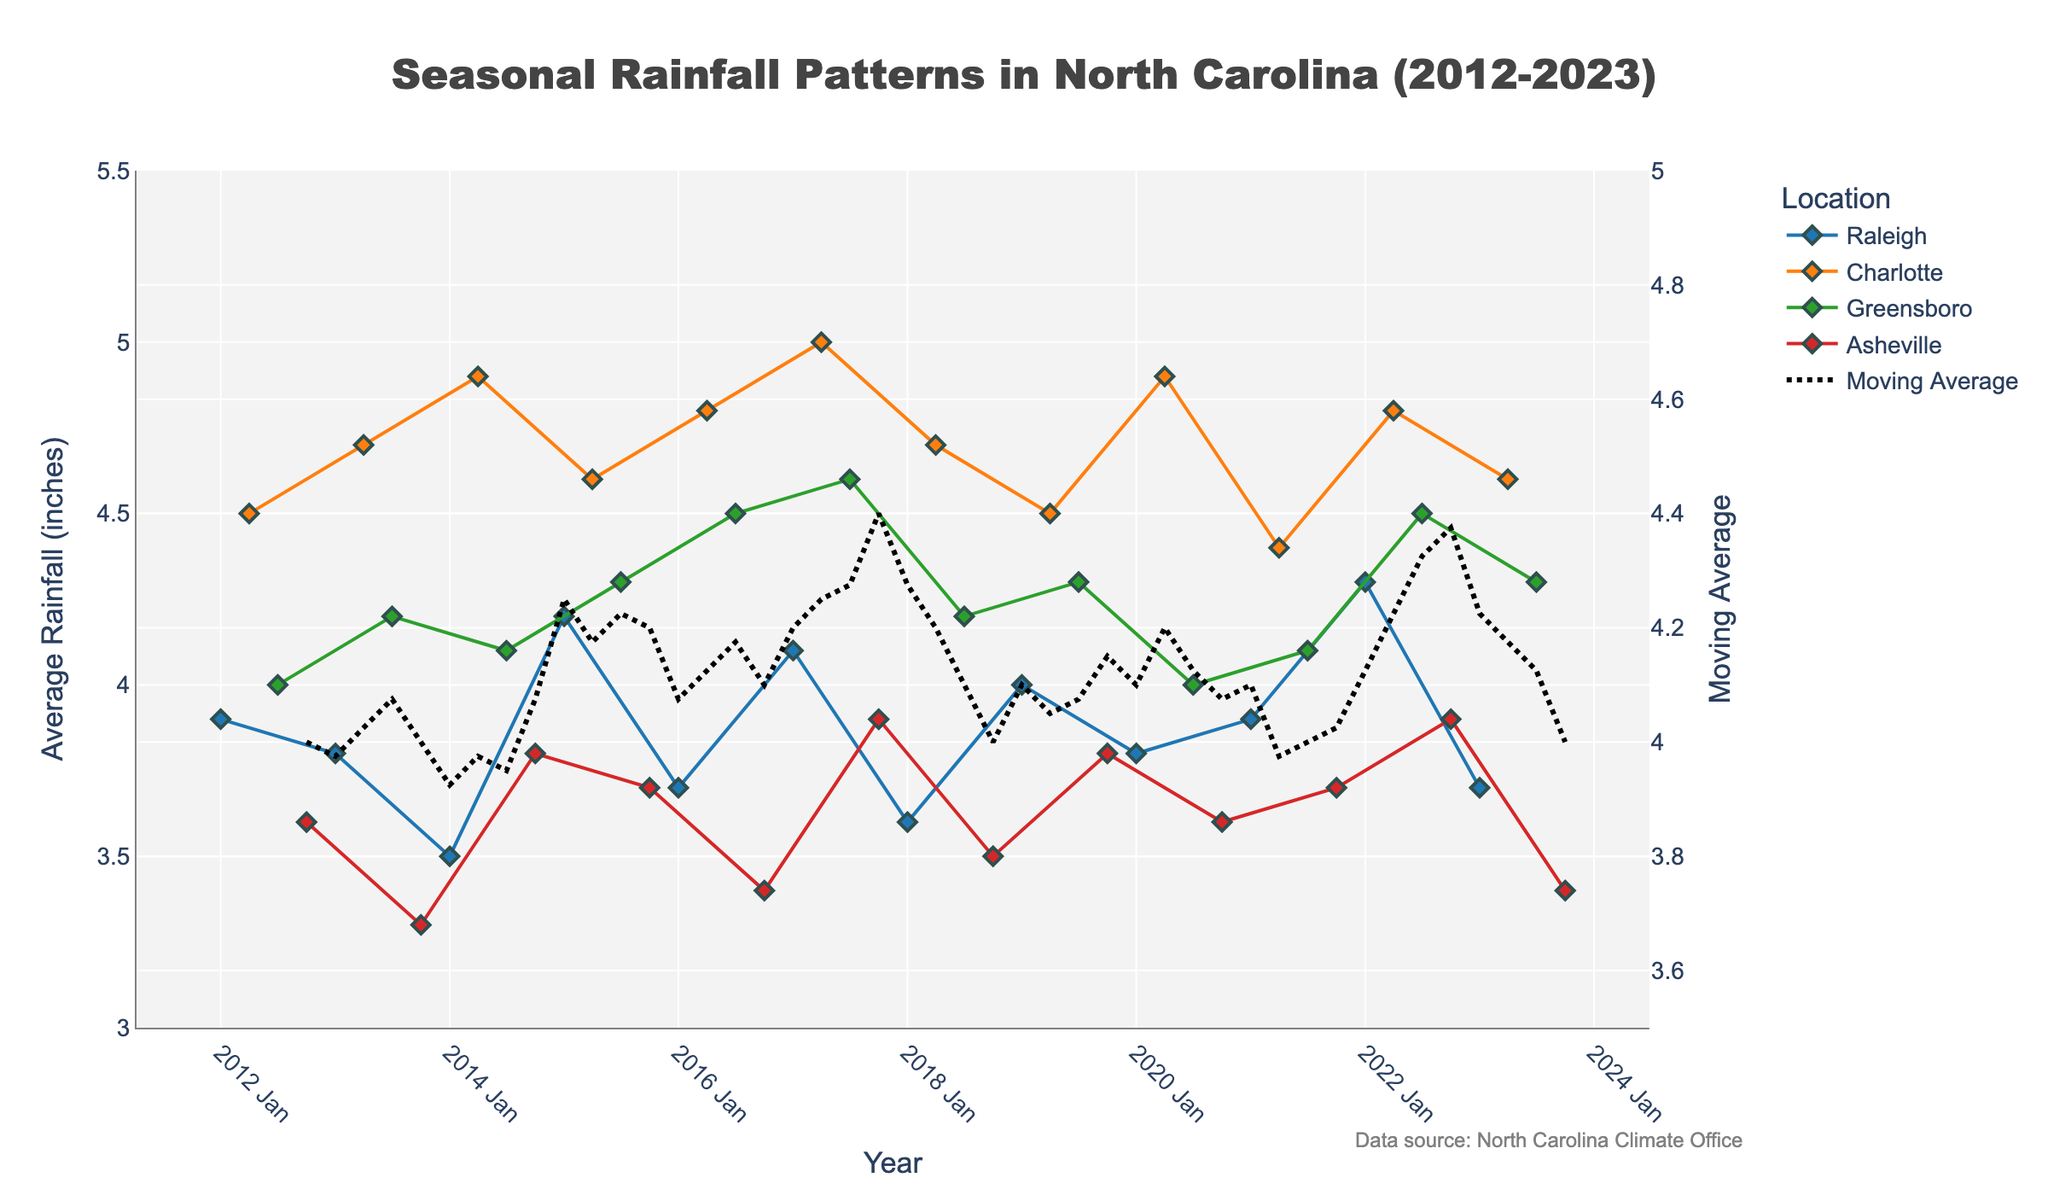What is the title of the figure? The title is located at the top of the figure and provides a summary of what the figure represents. According to the title, it describes "Seasonal Rainfall Patterns in North Carolina (2012-2023)."
Answer: Seasonal Rainfall Patterns in North Carolina (2012-2023) Which location had the highest rainfall in the winter of 2022? Locate points on the plot corresponding to Winter 2022 and check the values for each location. Raleigh shows the highest value of 4.3 inches of rainfall.
Answer: Raleigh What is the general trend of average rainfall in Charlotte during spring over the years? Track the line representing Charlotte in spring through each year. The rainfall seems generally stable with some fluctuations, staying around 4.4 to 5 inches.
Answer: Stable with fluctuations Compare the average rainfall in Asheville during the fall of 2017 and 2023. Which year had higher rainfall? Locate the points on the plot for Asheville during Fall for both 2017 and 2023 and compare their heights. The 2017 point is higher at 3.9 inches compared to 3.4 inches in 2023.
Answer: 2017 How does the moving average compare to the individual rainfall values across the seasons? Observe the moving average line compared to the individual data points. The moving average line smooths out the fluctuations, providing a steady trend around 4 to 4.8 inches while individual values vary more widely.
Answer: Steadier trend During which season and year did Greensboro experience its highest rainfall? Check each data point for Greensboro through all seasons and years. The highest point is in Summer 2017 with 4.6 inches.
Answer: Summer 2017 What is the range of average rainfall values represented on the y-axis for individual locations? Look at the scale of the y-axis for individual locations. The range goes from 3 to 5.5 inches.
Answer: 3 to 5.5 inches Which year had the highest moving average of rainfall? Follow the moving average line and find the point where it peaks the most. The moving average reaches its maximum around the year 2017.
Answer: 2017 Is there a specific season that tends to have lower rainfall in Asheville compared to others? Compare average rainfall values for Asheville across different seasons. Fall seems to have generally lower values compared to other seasons.
Answer: Fall Describe the rainfall pattern in Raleigh during winter throughout the years shown. Track the data points for Raleigh during winter across all years. The rainfall shows variability but generally stays between 3.5 to 4.3 inches, with occasional peaks and dips.
Answer: Variable, mostly between 3.5 to 4.3 inches 